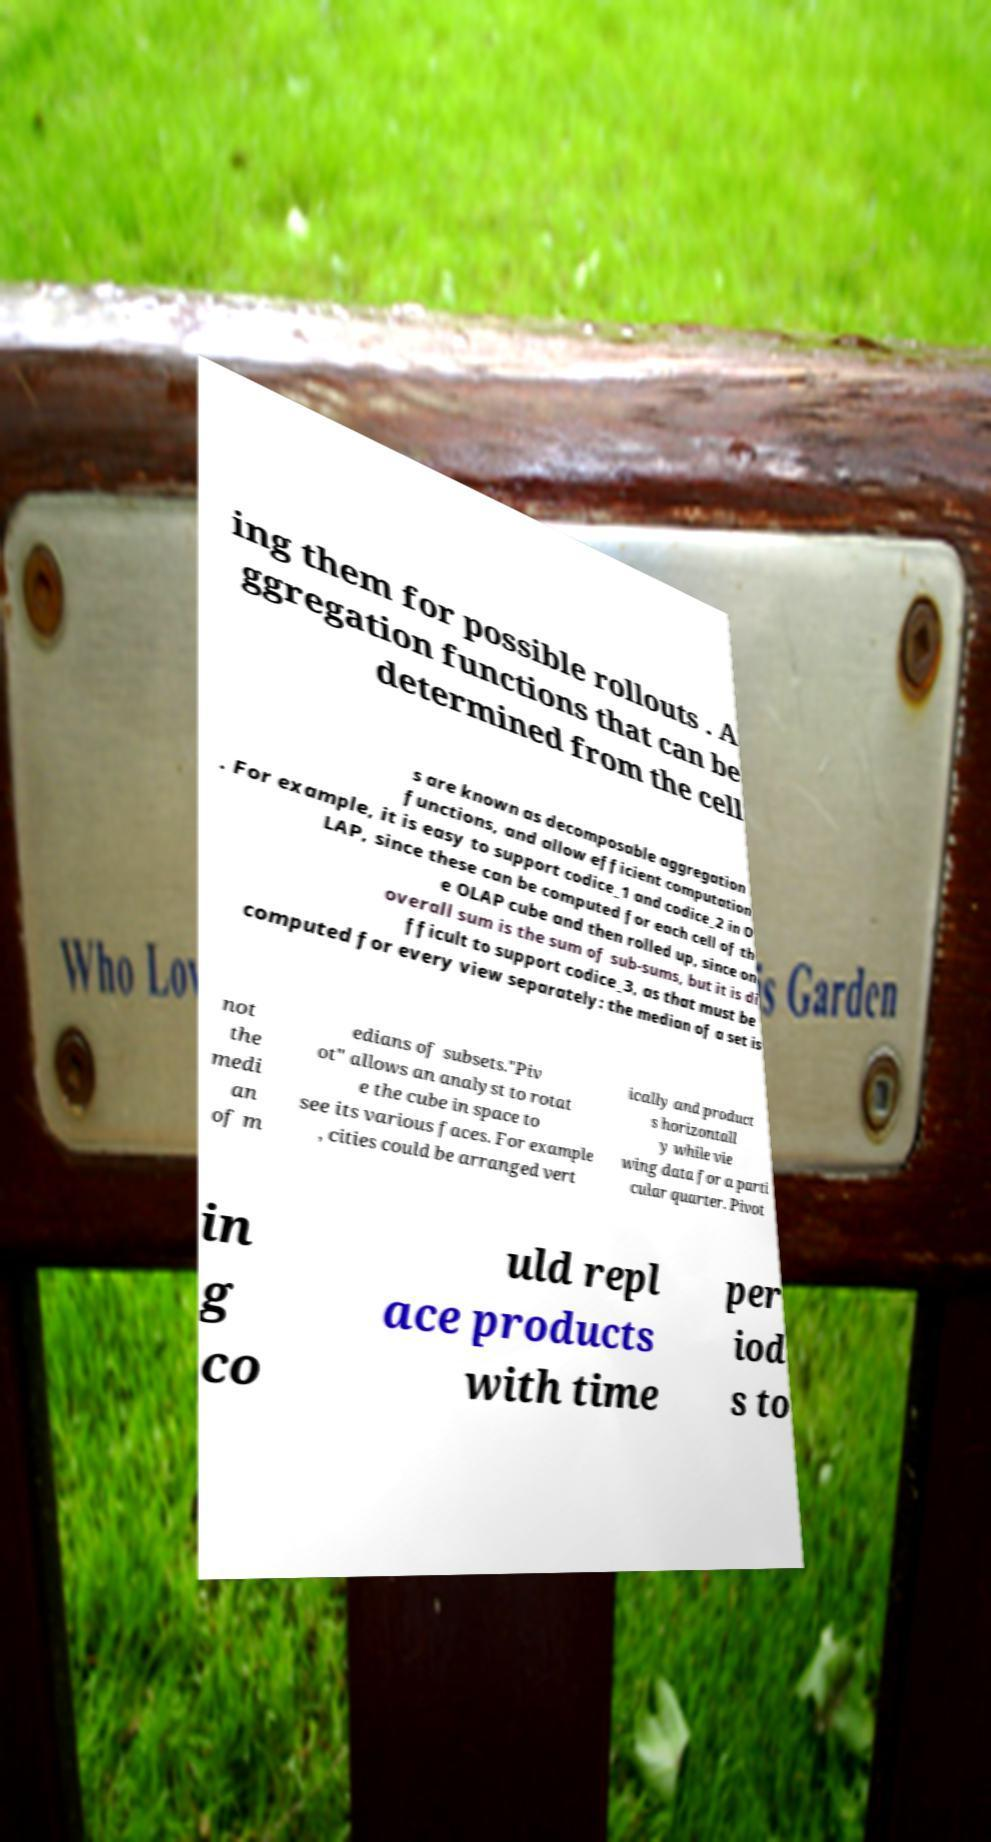What messages or text are displayed in this image? I need them in a readable, typed format. ing them for possible rollouts . A ggregation functions that can be determined from the cell s are known as decomposable aggregation functions, and allow efficient computation . For example, it is easy to support codice_1 and codice_2 in O LAP, since these can be computed for each cell of th e OLAP cube and then rolled up, since on overall sum is the sum of sub-sums, but it is di fficult to support codice_3, as that must be computed for every view separately: the median of a set is not the medi an of m edians of subsets."Piv ot" allows an analyst to rotat e the cube in space to see its various faces. For example , cities could be arranged vert ically and product s horizontall y while vie wing data for a parti cular quarter. Pivot in g co uld repl ace products with time per iod s to 